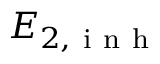Convert formula to latex. <formula><loc_0><loc_0><loc_500><loc_500>E _ { 2 , i n h }</formula> 